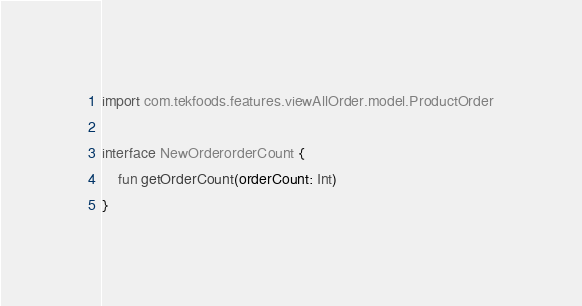Convert code to text. <code><loc_0><loc_0><loc_500><loc_500><_Kotlin_>
import com.tekfoods.features.viewAllOrder.model.ProductOrder

interface NewOrderorderCount {
    fun getOrderCount(orderCount: Int)
}</code> 